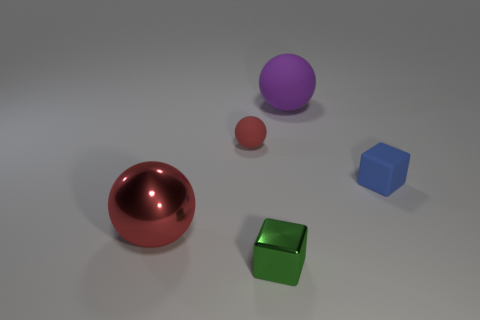There is a tiny blue cube in front of the big rubber object; what is its material?
Your response must be concise. Rubber. There is a tiny blue matte object; are there any big spheres in front of it?
Your answer should be compact. Yes. What is the shape of the green thing?
Provide a short and direct response. Cube. What number of objects are red objects that are behind the blue matte object or tiny metal objects?
Keep it short and to the point. 2. How many other things are there of the same color as the large metallic thing?
Give a very brief answer. 1. There is a big shiny thing; is its color the same as the small matte object to the left of the large purple sphere?
Your answer should be compact. Yes. The other big thing that is the same shape as the purple matte thing is what color?
Ensure brevity in your answer.  Red. Is the tiny blue thing made of the same material as the big thing that is behind the small red rubber object?
Your response must be concise. Yes. What color is the small ball?
Make the answer very short. Red. There is a big ball in front of the tiny matte ball behind the block behind the tiny shiny cube; what is its color?
Give a very brief answer. Red. 